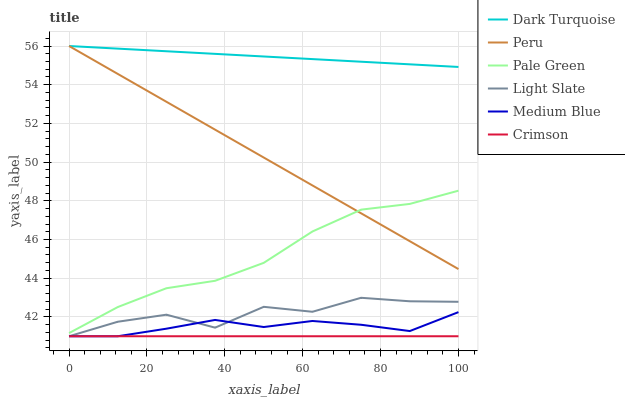Does Crimson have the minimum area under the curve?
Answer yes or no. Yes. Does Dark Turquoise have the maximum area under the curve?
Answer yes or no. Yes. Does Medium Blue have the minimum area under the curve?
Answer yes or no. No. Does Medium Blue have the maximum area under the curve?
Answer yes or no. No. Is Crimson the smoothest?
Answer yes or no. Yes. Is Light Slate the roughest?
Answer yes or no. Yes. Is Dark Turquoise the smoothest?
Answer yes or no. No. Is Dark Turquoise the roughest?
Answer yes or no. No. Does Light Slate have the lowest value?
Answer yes or no. Yes. Does Dark Turquoise have the lowest value?
Answer yes or no. No. Does Peru have the highest value?
Answer yes or no. Yes. Does Medium Blue have the highest value?
Answer yes or no. No. Is Medium Blue less than Peru?
Answer yes or no. Yes. Is Pale Green greater than Crimson?
Answer yes or no. Yes. Does Light Slate intersect Medium Blue?
Answer yes or no. Yes. Is Light Slate less than Medium Blue?
Answer yes or no. No. Is Light Slate greater than Medium Blue?
Answer yes or no. No. Does Medium Blue intersect Peru?
Answer yes or no. No. 